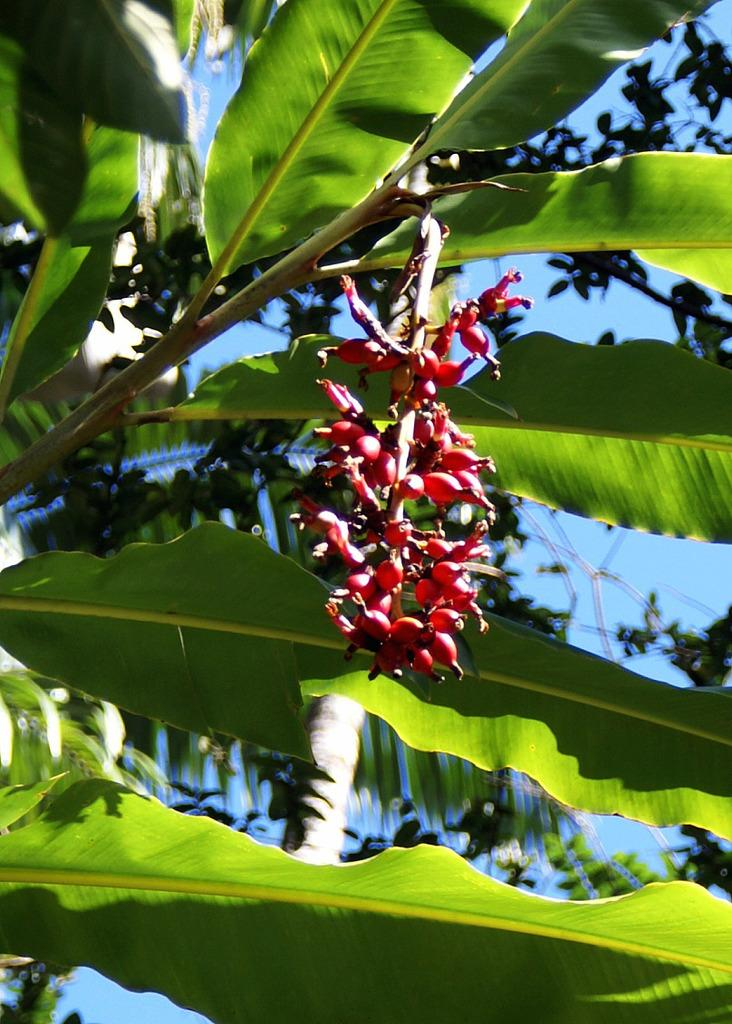What type of plant is featured in the image? There are leaves of a banana tree in the image. What can be seen hanging from the banana tree? There are fruits in the image, and they are red in color. What else is visible in the background of the image? There are leaves and the sky in the background of the image. How would you describe the sky in the image? The sky is visible in the background of the image, and it is clear. What type of scent can be smelled coming from the drain in the image? There is no drain present in the image, so it is not possible to determine any scent. 